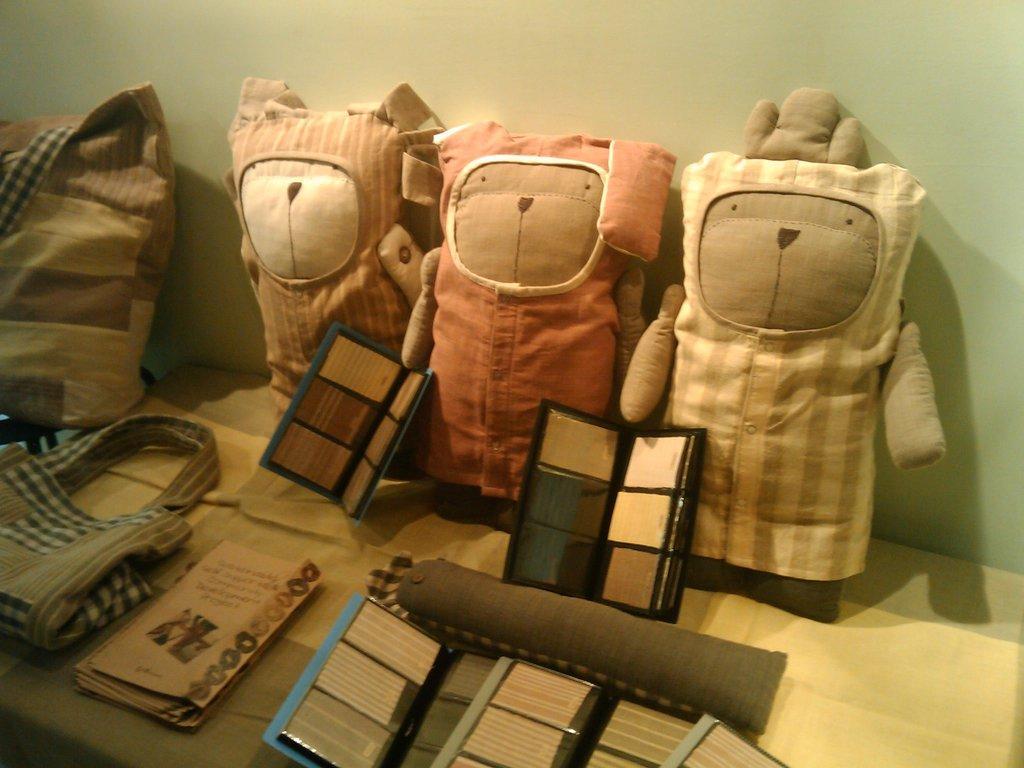Describe this image in one or two sentences. In this picture I can see papers, toys, bags and some other objects on the table, and in the background there is a wall. 